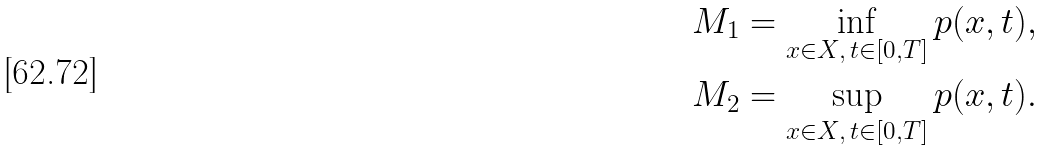Convert formula to latex. <formula><loc_0><loc_0><loc_500><loc_500>M _ { 1 } = \inf _ { x \in X , \, t \in [ 0 , T ] } p ( x , t ) , \\ M _ { 2 } = \sup _ { x \in X , \, t \in [ 0 , T ] } p ( x , t ) .</formula> 